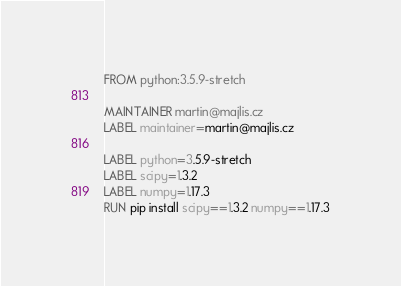Convert code to text. <code><loc_0><loc_0><loc_500><loc_500><_Dockerfile_>FROM python:3.5.9-stretch

MAINTAINER martin@majlis.cz
LABEL maintainer=martin@majlis.cz

LABEL python=3.5.9-stretch
LABEL scipy=1.3.2
LABEL numpy=1.17.3
RUN pip install scipy==1.3.2 numpy==1.17.3
</code> 